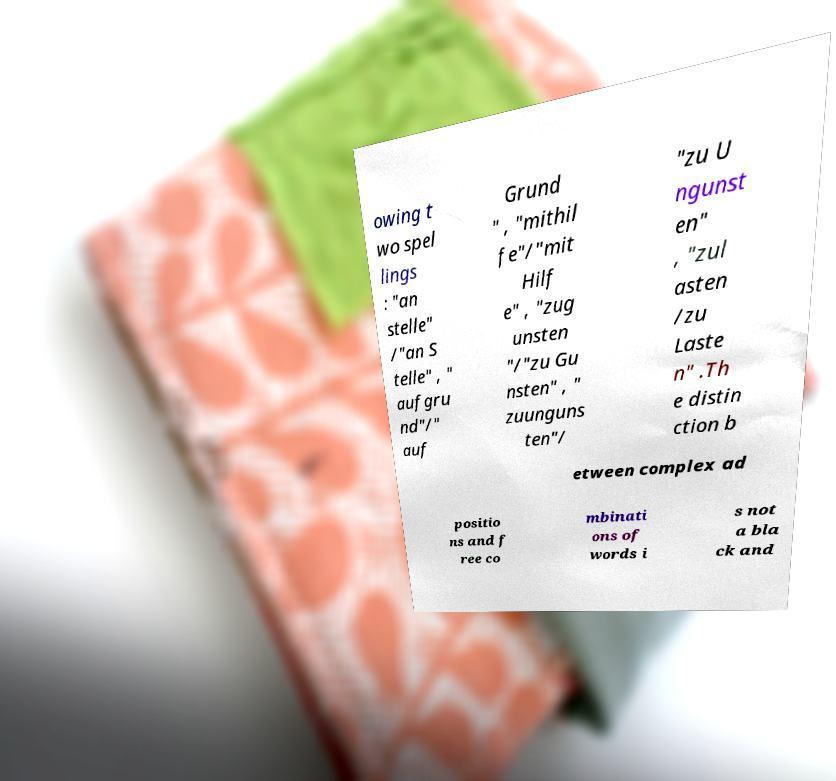Please identify and transcribe the text found in this image. owing t wo spel lings : "an stelle" /"an S telle" , " aufgru nd"/" auf Grund " , "mithil fe"/"mit Hilf e" , "zug unsten "/"zu Gu nsten" , " zuunguns ten"/ "zu U ngunst en" , "zul asten /zu Laste n" .Th e distin ction b etween complex ad positio ns and f ree co mbinati ons of words i s not a bla ck and 